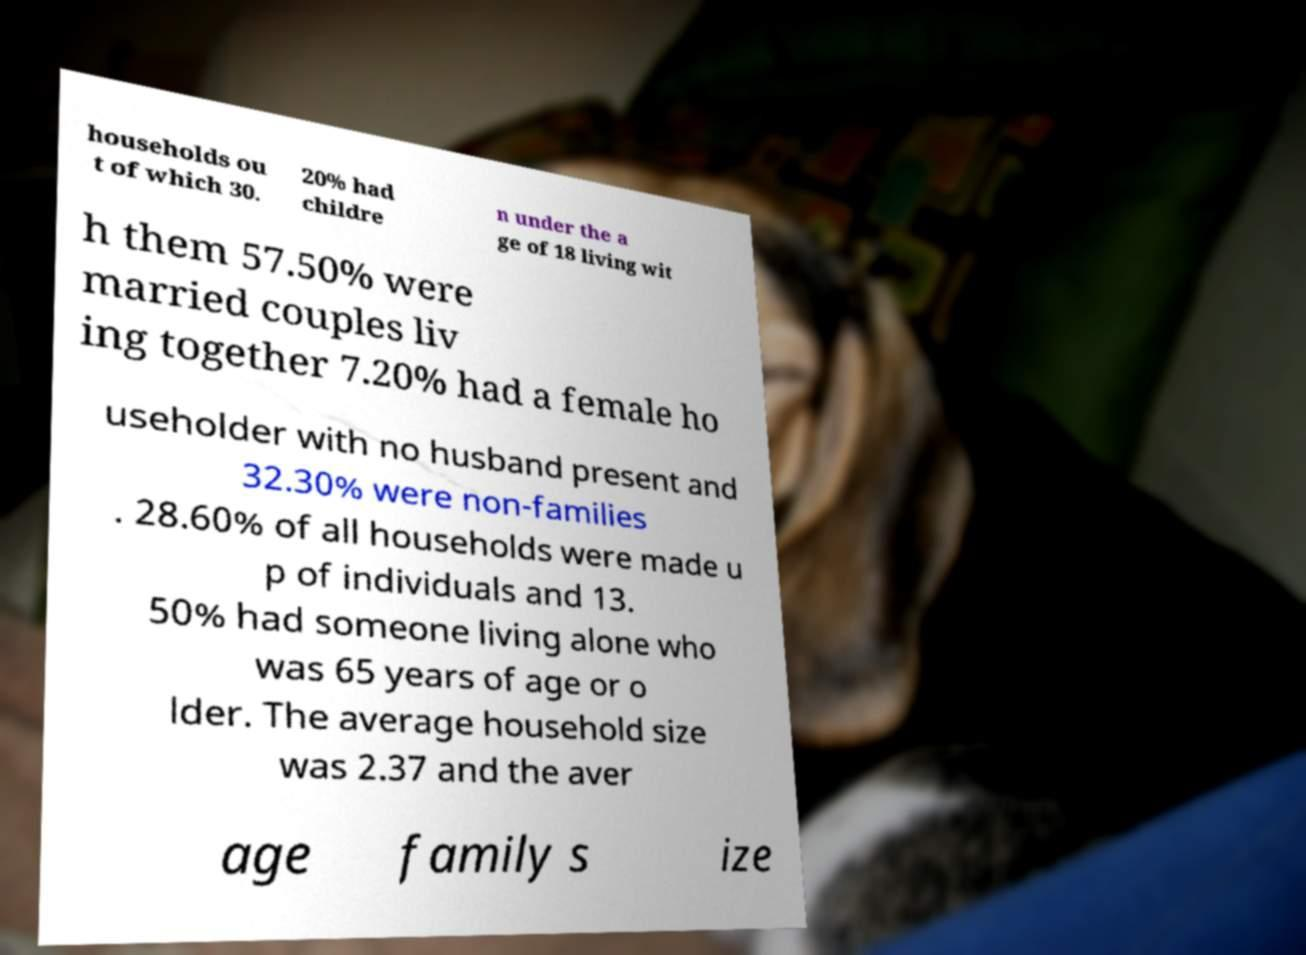For documentation purposes, I need the text within this image transcribed. Could you provide that? households ou t of which 30. 20% had childre n under the a ge of 18 living wit h them 57.50% were married couples liv ing together 7.20% had a female ho useholder with no husband present and 32.30% were non-families . 28.60% of all households were made u p of individuals and 13. 50% had someone living alone who was 65 years of age or o lder. The average household size was 2.37 and the aver age family s ize 